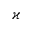<formula> <loc_0><loc_0><loc_500><loc_500>\varkappa</formula> 